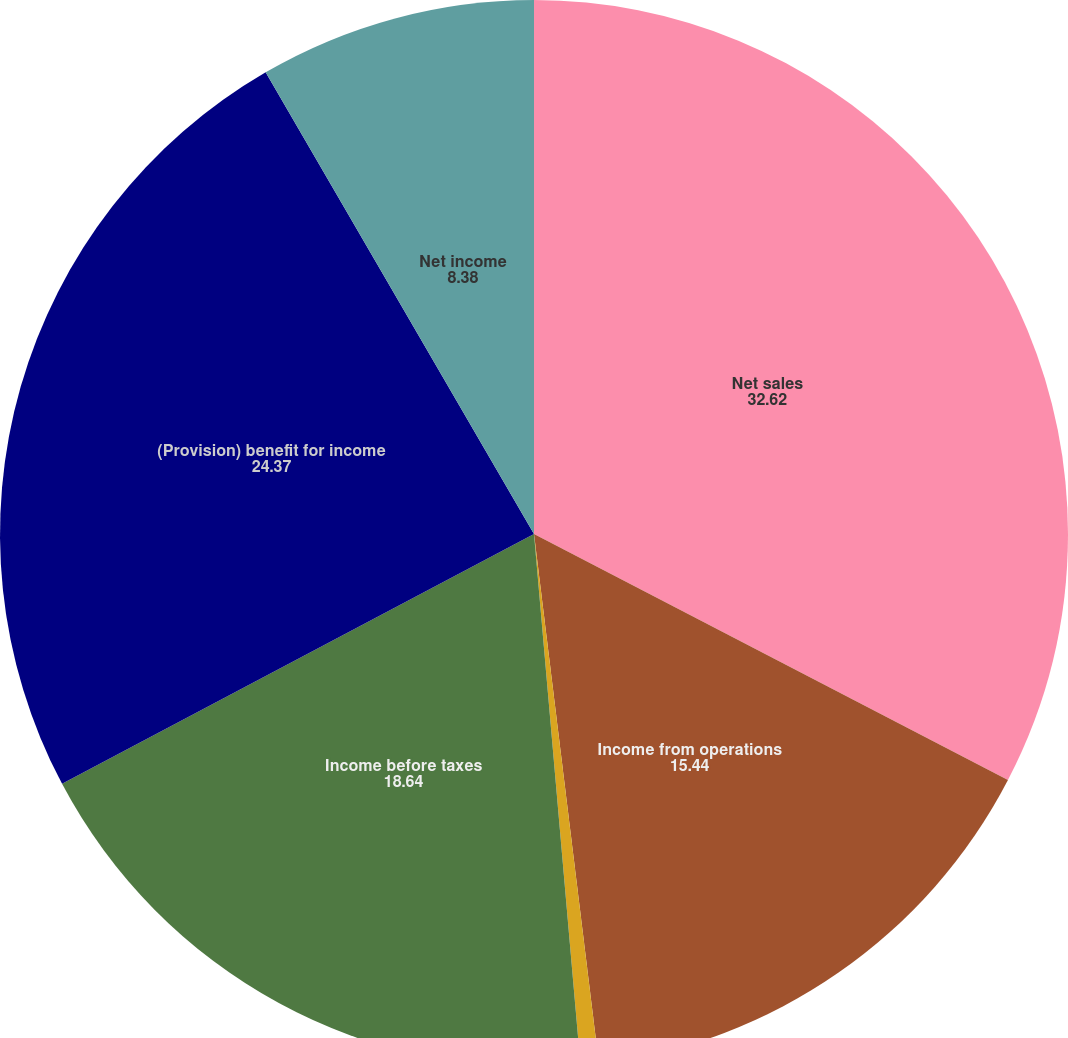<chart> <loc_0><loc_0><loc_500><loc_500><pie_chart><fcel>Net sales<fcel>Income from operations<fcel>Interest expense net<fcel>Income before taxes<fcel>(Provision) benefit for income<fcel>Net income<nl><fcel>32.62%<fcel>15.44%<fcel>0.55%<fcel>18.64%<fcel>24.37%<fcel>8.38%<nl></chart> 